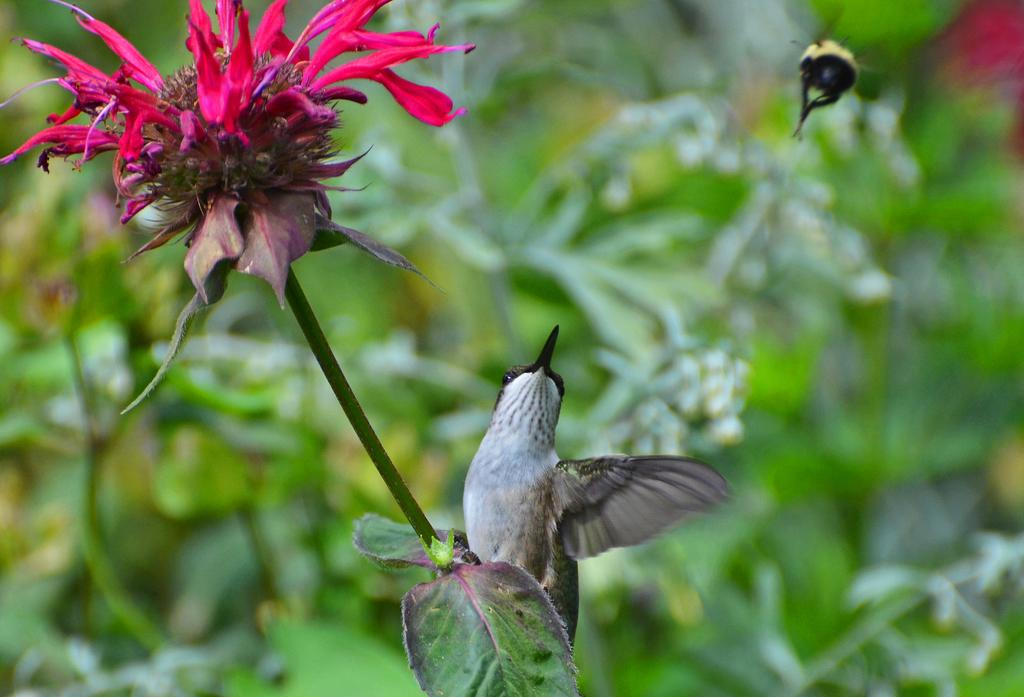What is the main subject of the image? There is a flower in the image. Are there any other living creatures present in the image? Yes, there is a bird on the plant in the image. How would you describe the background of the image? The background of the image is blurred. Who is the creator of the flower in the image? The image does not provide information about the creator of the flower. Flowers are naturally occurring plants and are not created by individuals. 